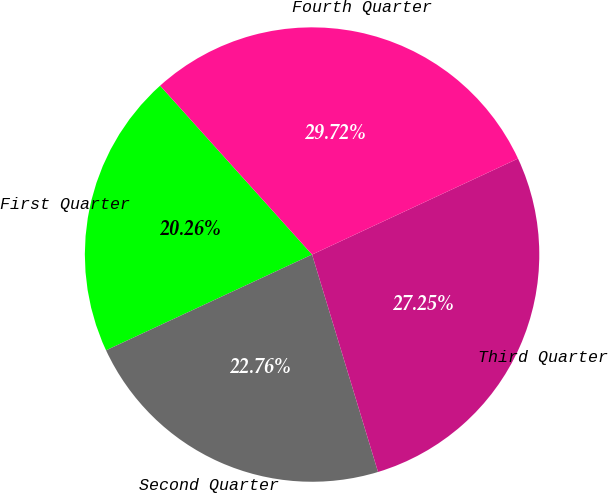<chart> <loc_0><loc_0><loc_500><loc_500><pie_chart><fcel>First Quarter<fcel>Second Quarter<fcel>Third Quarter<fcel>Fourth Quarter<nl><fcel>20.26%<fcel>22.76%<fcel>27.25%<fcel>29.72%<nl></chart> 